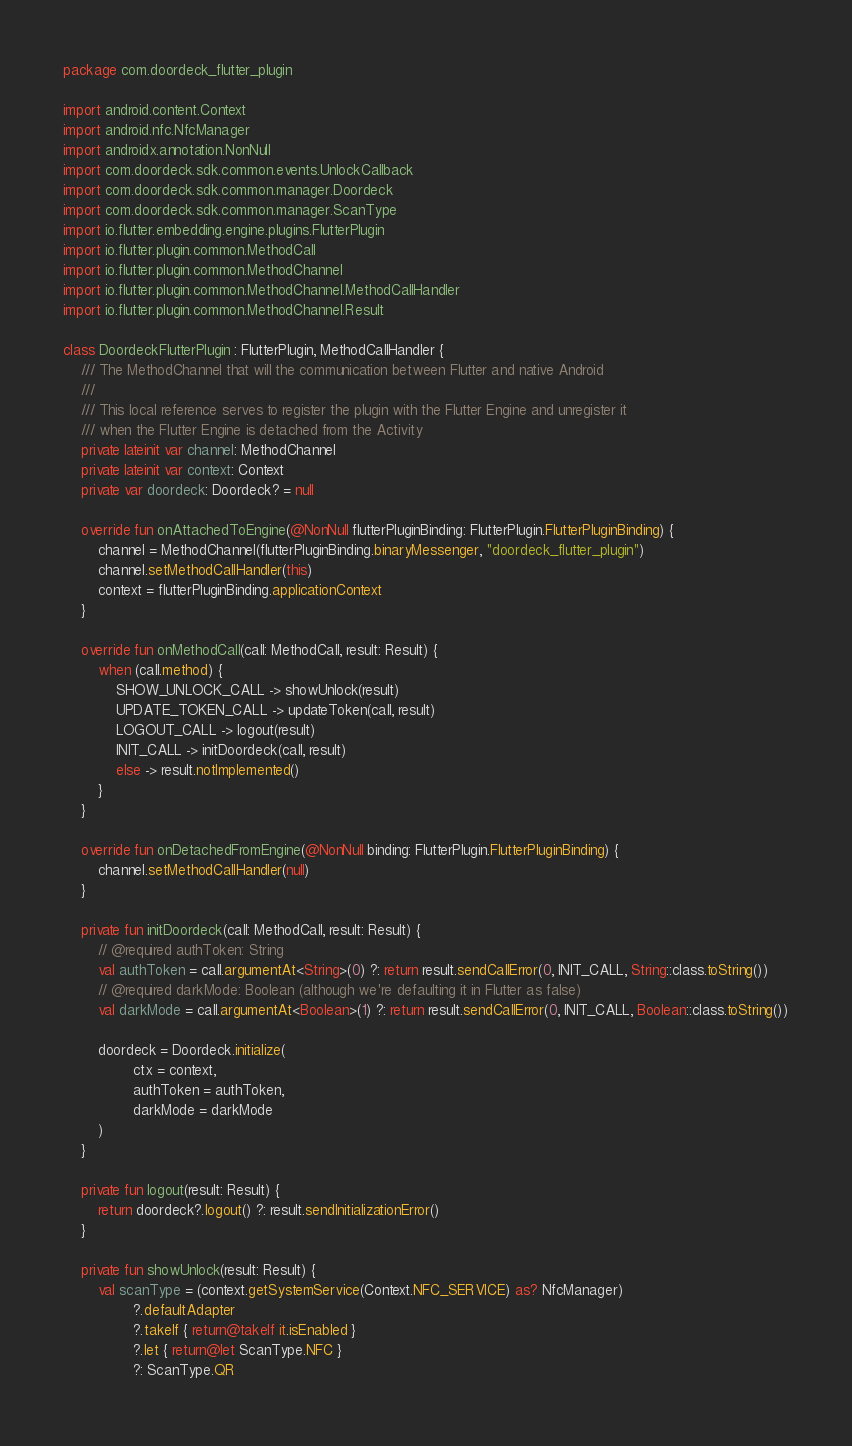<code> <loc_0><loc_0><loc_500><loc_500><_Kotlin_>package com.doordeck_flutter_plugin

import android.content.Context
import android.nfc.NfcManager
import androidx.annotation.NonNull
import com.doordeck.sdk.common.events.UnlockCallback
import com.doordeck.sdk.common.manager.Doordeck
import com.doordeck.sdk.common.manager.ScanType
import io.flutter.embedding.engine.plugins.FlutterPlugin
import io.flutter.plugin.common.MethodCall
import io.flutter.plugin.common.MethodChannel
import io.flutter.plugin.common.MethodChannel.MethodCallHandler
import io.flutter.plugin.common.MethodChannel.Result

class DoordeckFlutterPlugin : FlutterPlugin, MethodCallHandler {
    /// The MethodChannel that will the communication between Flutter and native Android
    ///
    /// This local reference serves to register the plugin with the Flutter Engine and unregister it
    /// when the Flutter Engine is detached from the Activity
    private lateinit var channel: MethodChannel
    private lateinit var context: Context
    private var doordeck: Doordeck? = null

    override fun onAttachedToEngine(@NonNull flutterPluginBinding: FlutterPlugin.FlutterPluginBinding) {
        channel = MethodChannel(flutterPluginBinding.binaryMessenger, "doordeck_flutter_plugin")
        channel.setMethodCallHandler(this)
        context = flutterPluginBinding.applicationContext
    }

    override fun onMethodCall(call: MethodCall, result: Result) {
        when (call.method) {
            SHOW_UNLOCK_CALL -> showUnlock(result)
            UPDATE_TOKEN_CALL -> updateToken(call, result)
            LOGOUT_CALL -> logout(result)
            INIT_CALL -> initDoordeck(call, result)
            else -> result.notImplemented()
        }
    }

    override fun onDetachedFromEngine(@NonNull binding: FlutterPlugin.FlutterPluginBinding) {
        channel.setMethodCallHandler(null)
    }

    private fun initDoordeck(call: MethodCall, result: Result) {
        // @required authToken: String
        val authToken = call.argumentAt<String>(0) ?: return result.sendCallError(0, INIT_CALL, String::class.toString())
        // @required darkMode: Boolean (although we're defaulting it in Flutter as false)
        val darkMode = call.argumentAt<Boolean>(1) ?: return result.sendCallError(0, INIT_CALL, Boolean::class.toString())

        doordeck = Doordeck.initialize(
                ctx = context,
                authToken = authToken,
                darkMode = darkMode
        )
    }

    private fun logout(result: Result) {
        return doordeck?.logout() ?: result.sendInitializationError()
    }

    private fun showUnlock(result: Result) {
        val scanType = (context.getSystemService(Context.NFC_SERVICE) as? NfcManager)
                ?.defaultAdapter
                ?.takeIf { return@takeIf it.isEnabled }
                ?.let { return@let ScanType.NFC }
                ?: ScanType.QR
</code> 